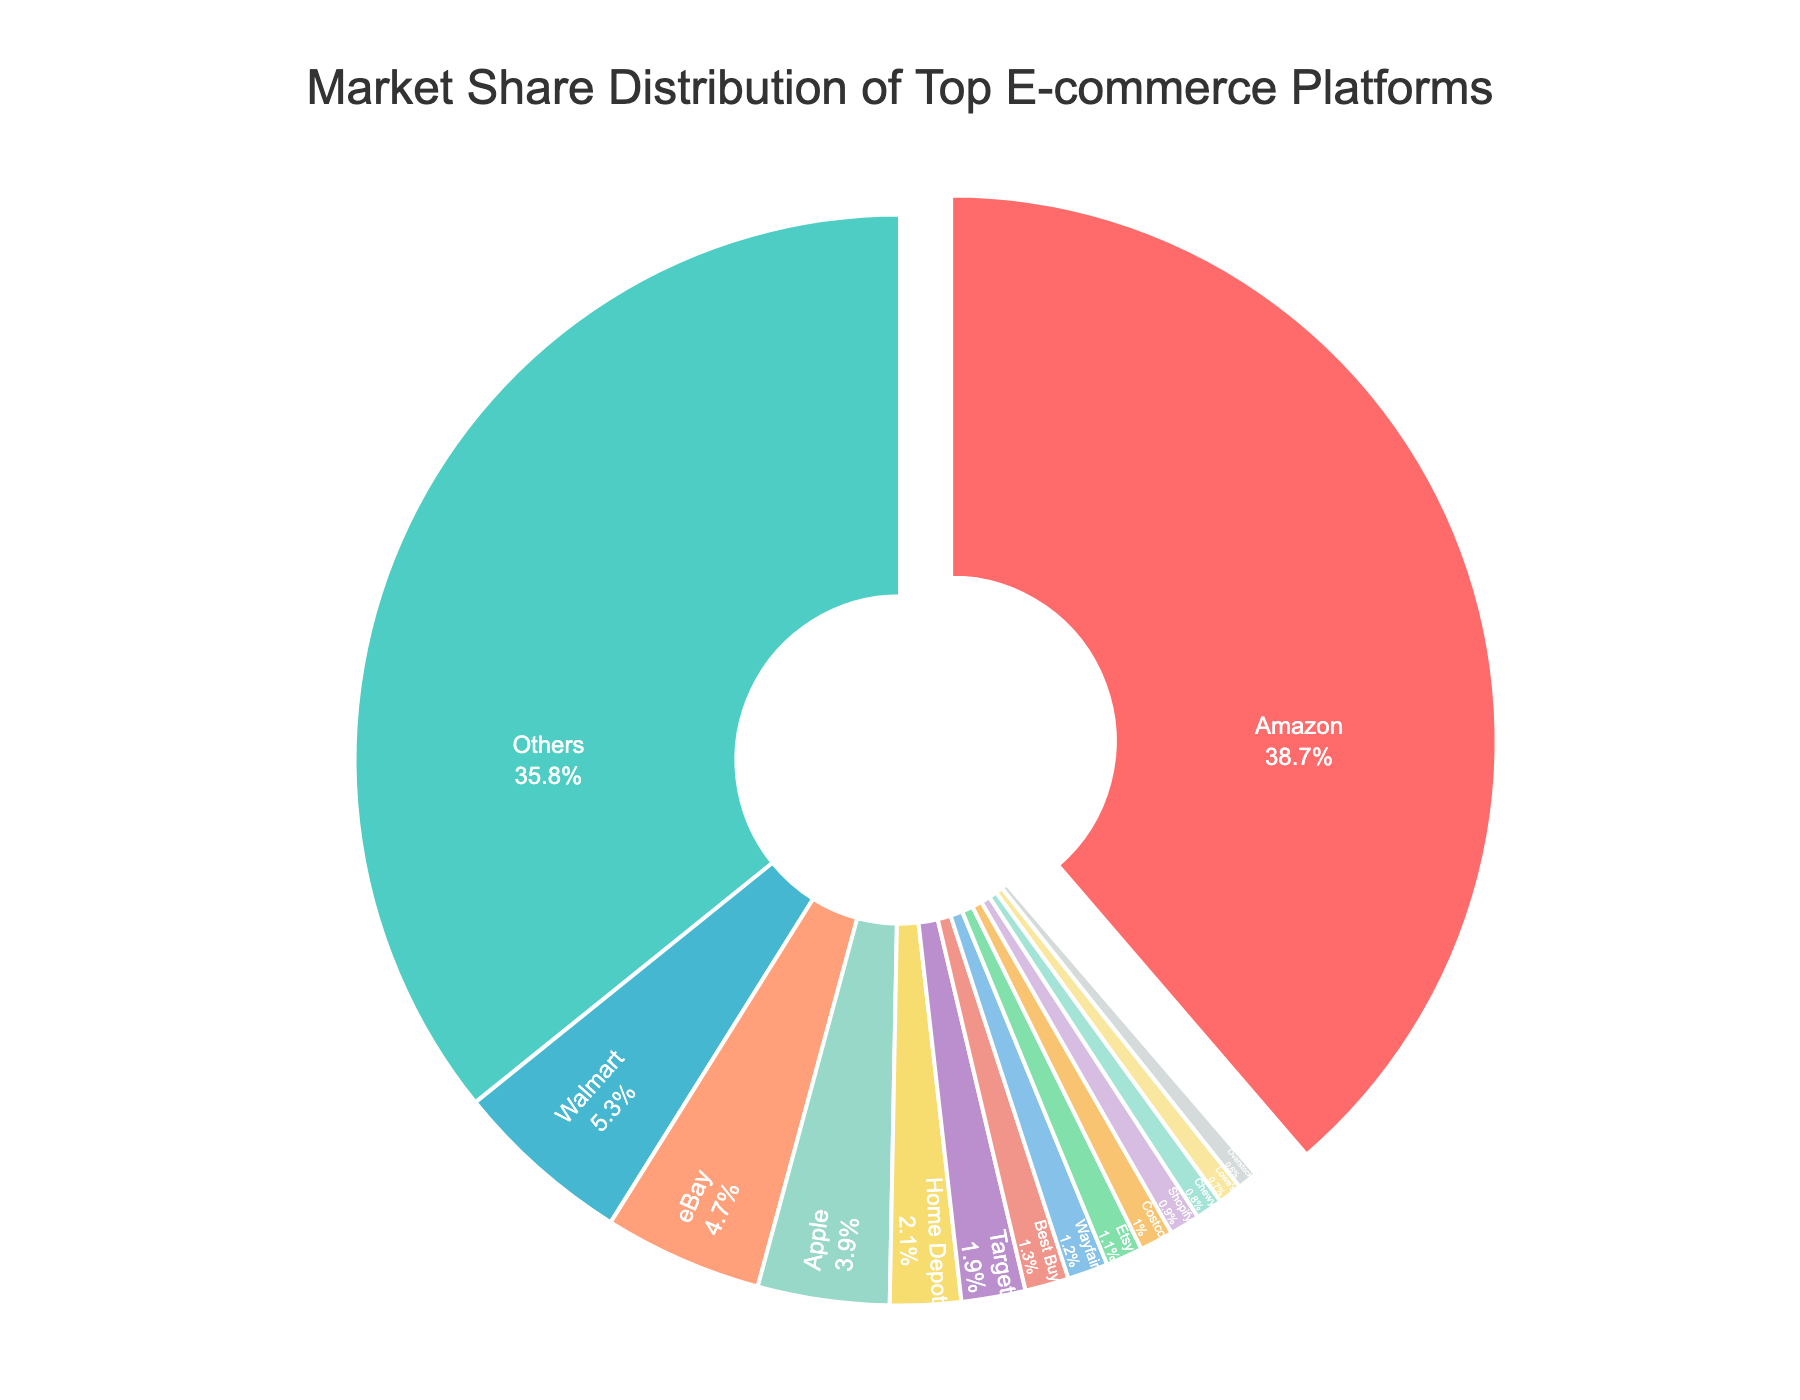what is Amazon's market share? Locate Amazon in the pie chart. The label on Amazon's segment shows its market share as 38.7%.
Answer: 38.7% How much more is Walmart's market share compared to eBay's? Walmart's market share is 5.3%, and eBay's market share is 4.7%. The difference is calculated as 5.3% - 4.7% = 0.6%.
Answer: 0.6% What is the combined market share of Amazon, Walmart, and eBay? Add the market shares of Amazon (38.7%), Walmart (5.3%), and eBay (4.7%). The combined market share is 38.7% + 5.3% + 4.7% = 48.7%.
Answer: 48.7% Which company has the smallest market share, and what is its value? Locate the segment with the smallest market share. Lowe's has the smallest share at 0.7%.
Answer: Lowe's, 0.7% How does the market share of Apple compare to that of the total 'Others' segment? Apple's market share is 3.9%, while the 'Others' segment has a share of 35.8%. By comparing, 35.8% is significantly larger than 3.9%.
Answer: 'Others' is significantly larger If we combine the market shares of Target, Best Buy, and Wayfair, will it be more or less than Apple's market share? Add the market shares of Target (1.9%), Best Buy (1.3%), and Wayfair (1.2%) to find their combined market share: 1.9% + 1.3% + 1.2% = 4.4%. Apple's market share is 3.9%, so 4.4% is greater than 3.9%.
Answer: More (4.4%) How much larger is the market share of Amazon compared to the combined market share of Apple and Walmart? Combine Apple's (3.9%) and Walmart's (5.3%) market shares to find their total: 3.9% + 5.3% = 9.2%. Amazon's market share is 38.7%, so the difference is 38.7% - 9.2% = 29.5%.
Answer: 29.5% What is the visual indication of the largest market share segment? In the pie chart, the segment for Amazon is pulled out slightly from the rest to indicate it has the largest market share.
Answer: Pulled out segment Which company's market share is indicated by a maroon color, and what is its value? Find the segment colored in maroon, which corresponds to Etsy with a market share of 1.1%.
Answer: Etsy, 1.1% If the 'Others' segment is broken down into an equal number of segments as the named companies, what would be the approximate average market share of each segment? The 'Others' segment totals 35.8%. There are 14 named companies, so we assume 14 equal segments for 'Others'. The average market share is 35.8% / 14 ≈ 2.56%.
Answer: 2.56% 